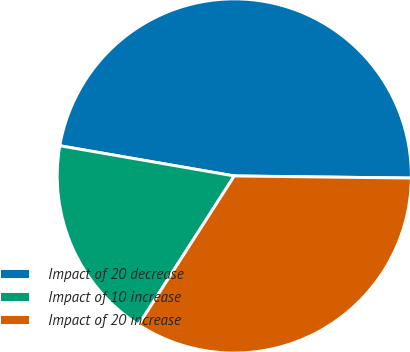<chart> <loc_0><loc_0><loc_500><loc_500><pie_chart><fcel>Impact of 20 decrease<fcel>Impact of 10 increase<fcel>Impact of 20 increase<nl><fcel>47.46%<fcel>18.64%<fcel>33.9%<nl></chart> 